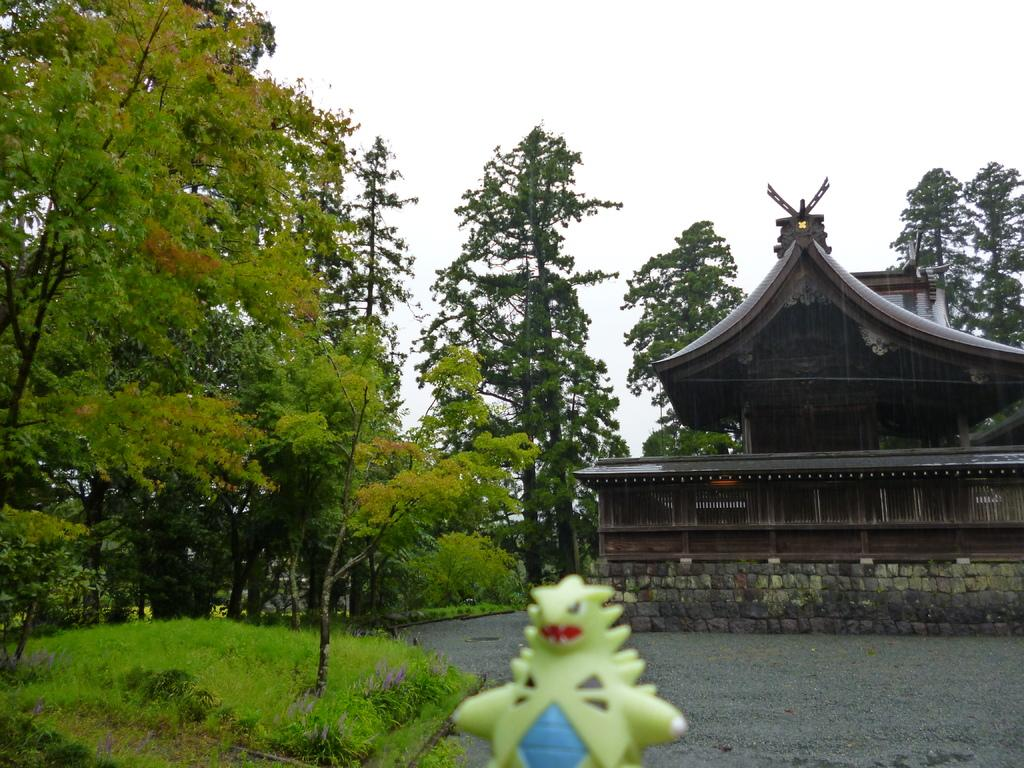What object is located at the bottom of the image? There is a toy at the bottom of the image. What can be seen in the middle of the image? There are trees and a building in the middle of the image. What is visible in the background of the image? The sky is visible in the background of the image. What type of wool is being spun by the sheep in the image? There are no sheep or wool present in the image; it features a toy, trees, a building, and the sky. How many balls are visible in the image? There are no balls present in the image. 